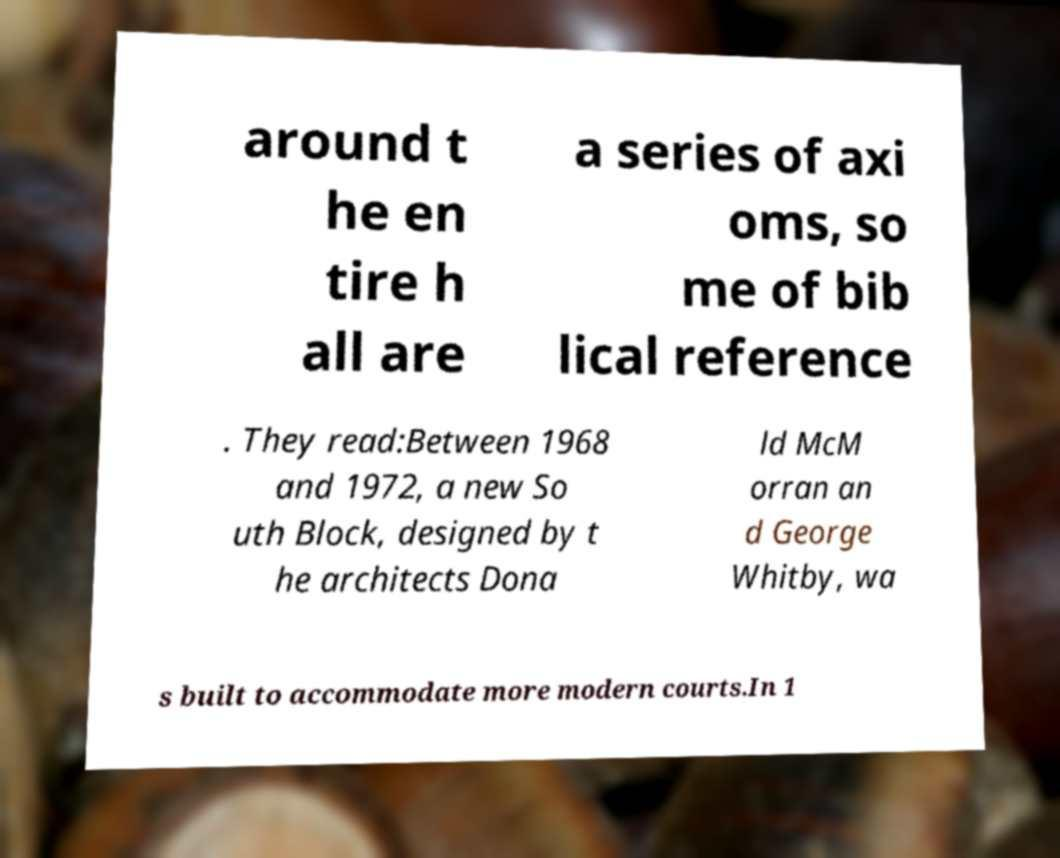Could you assist in decoding the text presented in this image and type it out clearly? around t he en tire h all are a series of axi oms, so me of bib lical reference . They read:Between 1968 and 1972, a new So uth Block, designed by t he architects Dona ld McM orran an d George Whitby, wa s built to accommodate more modern courts.In 1 